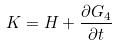<formula> <loc_0><loc_0><loc_500><loc_500>K = H + \frac { \partial G _ { 4 } } { \partial t }</formula> 